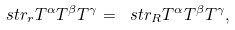<formula> <loc_0><loc_0><loc_500><loc_500>\ s t r _ { r } T ^ { \alpha } T ^ { \beta } T ^ { \gamma } = \ s t r _ { R } T ^ { \alpha } T ^ { \beta } T ^ { \gamma } ,</formula> 